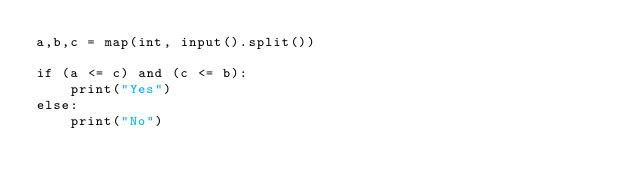<code> <loc_0><loc_0><loc_500><loc_500><_Python_>a,b,c = map(int, input().split())

if (a <= c) and (c <= b):
    print("Yes")
else:
    print("No")</code> 